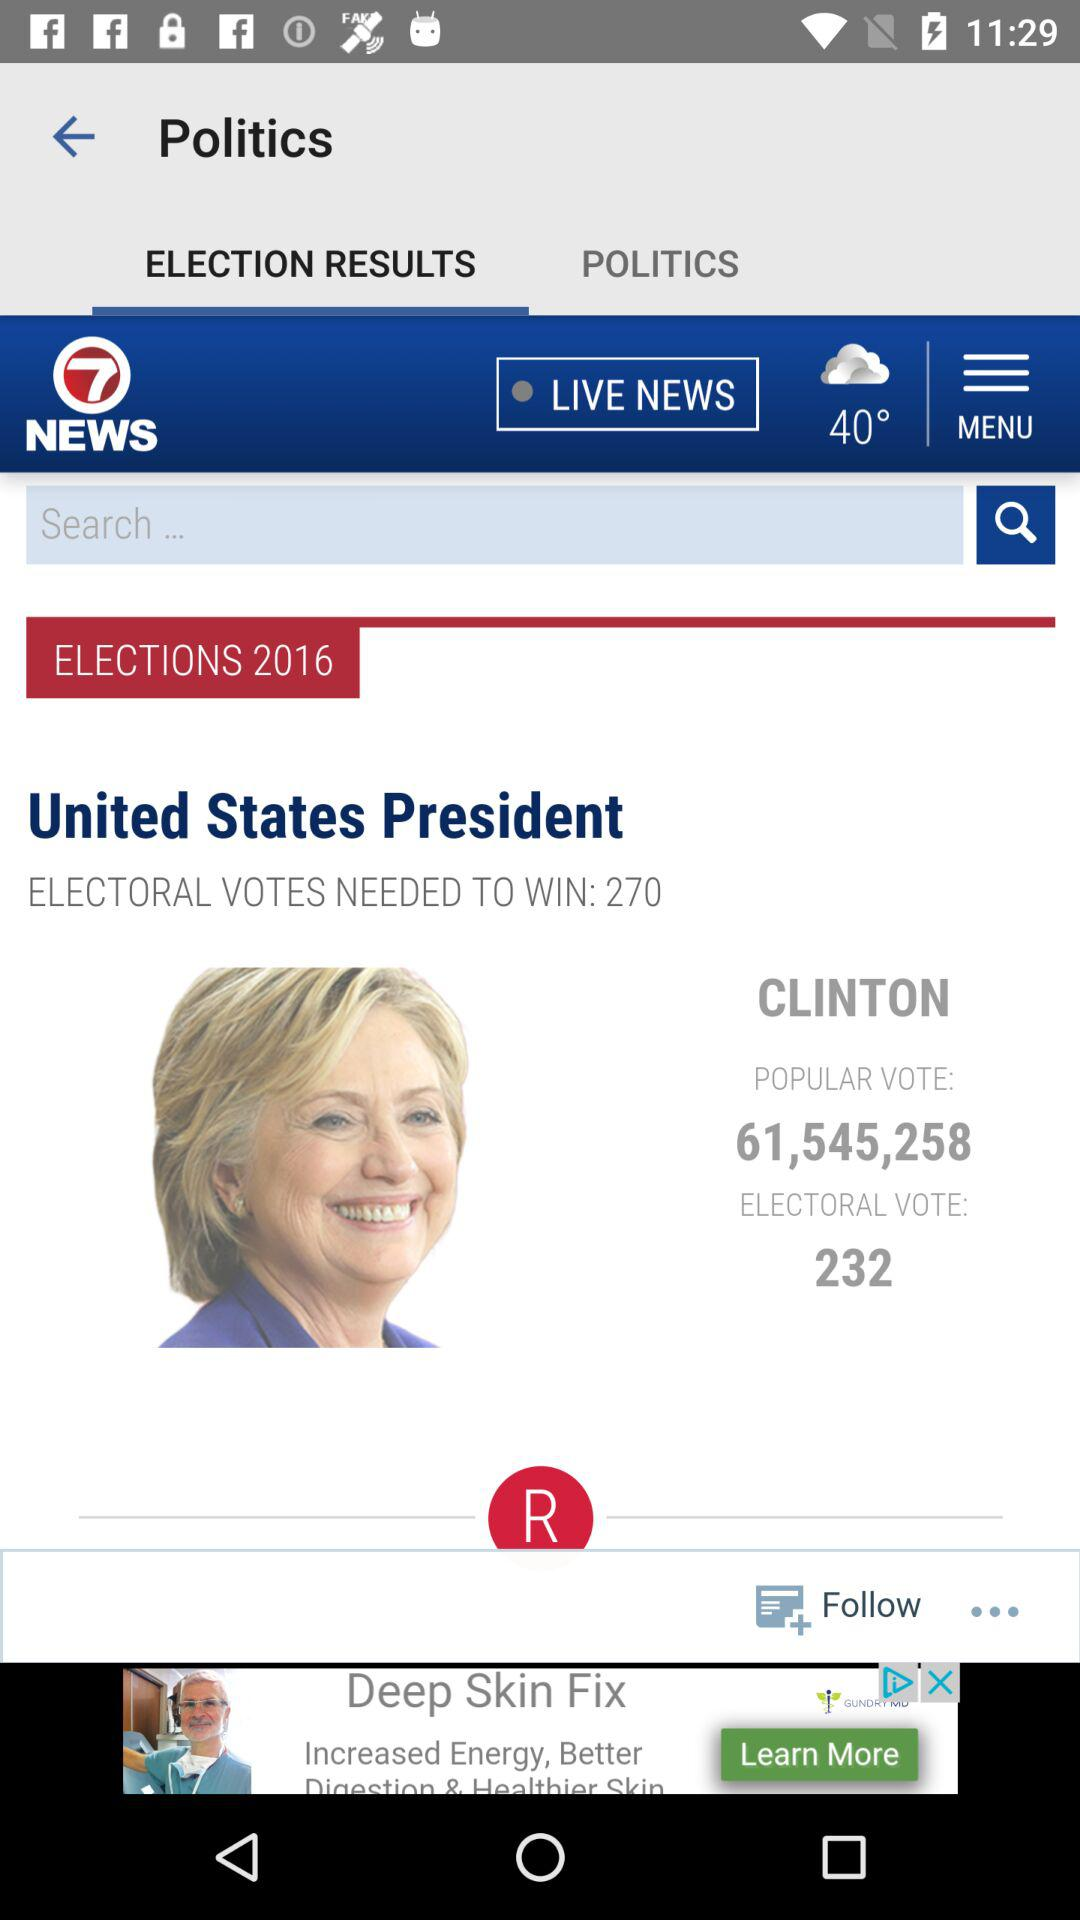How many electoral votes does Clinton have? Clinton has 232 electoral votes. 